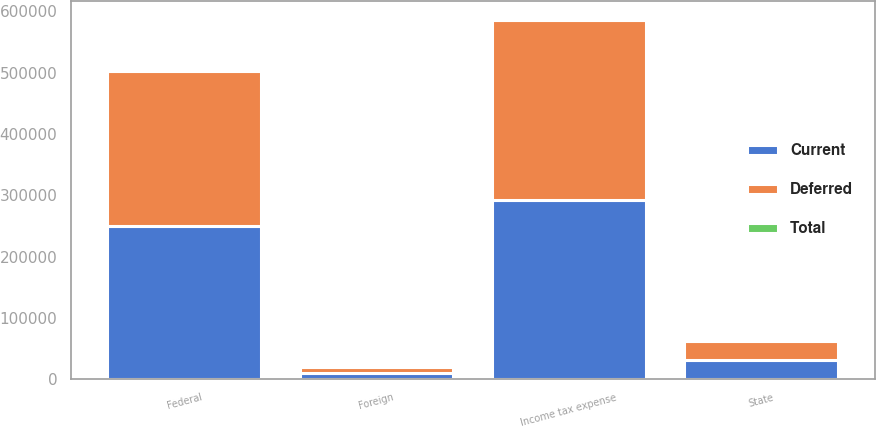<chart> <loc_0><loc_0><loc_500><loc_500><stacked_bar_chart><ecel><fcel>Federal<fcel>State<fcel>Foreign<fcel>Income tax expense<nl><fcel>Current<fcel>250527<fcel>30768<fcel>10518<fcel>291813<nl><fcel>Total<fcel>1919<fcel>256<fcel>704<fcel>1471<nl><fcel>Deferred<fcel>252446<fcel>31024<fcel>9814<fcel>293284<nl></chart> 